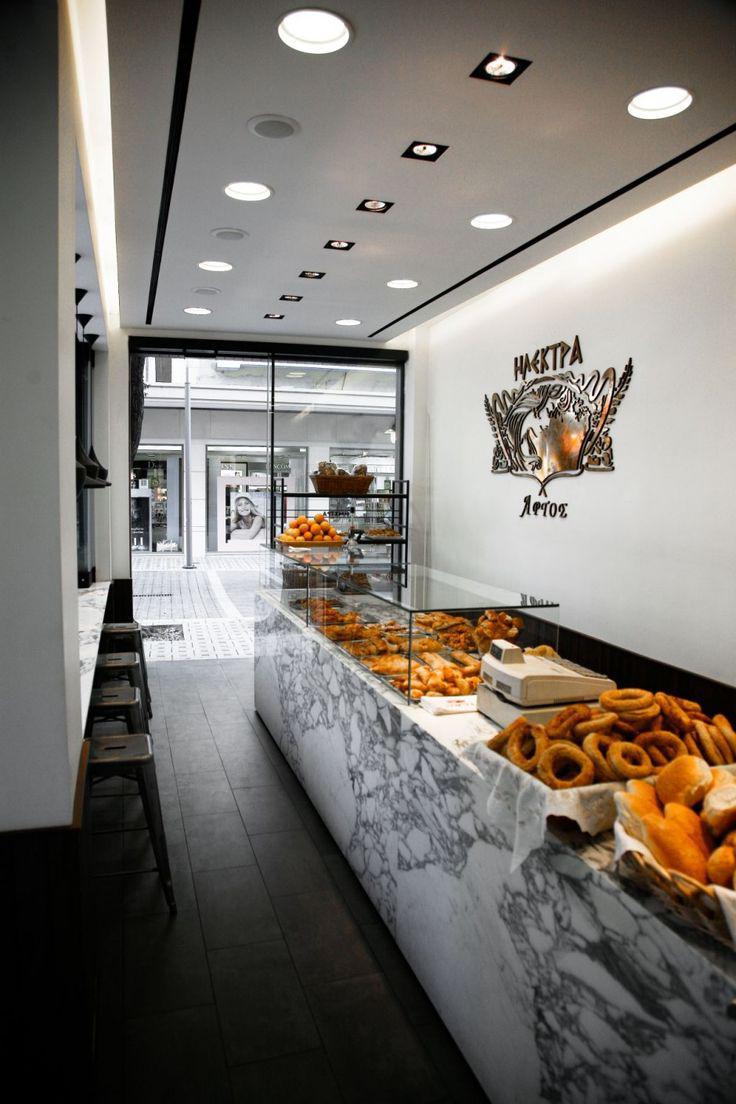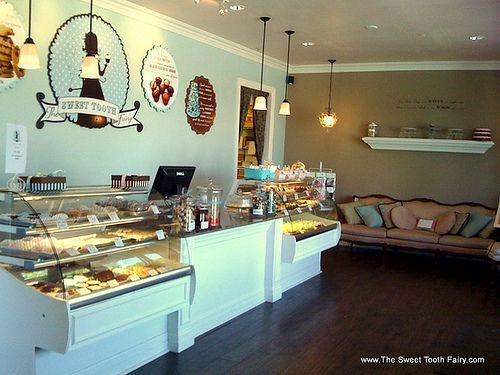The first image is the image on the left, the second image is the image on the right. Examine the images to the left and right. Is the description "There are at least five haning lights in the image on the right." accurate? Answer yes or no. Yes. 